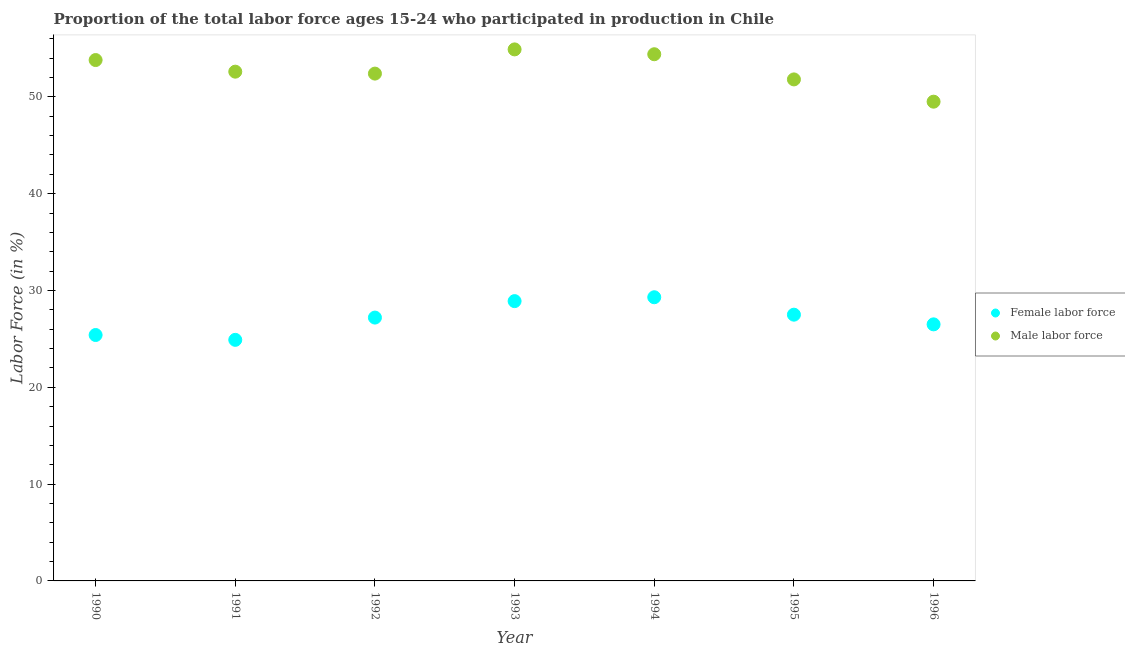How many different coloured dotlines are there?
Ensure brevity in your answer.  2. What is the percentage of female labor force in 1992?
Your answer should be very brief. 27.2. Across all years, what is the maximum percentage of male labour force?
Your answer should be very brief. 54.9. Across all years, what is the minimum percentage of female labor force?
Your answer should be very brief. 24.9. In which year was the percentage of male labour force maximum?
Offer a terse response. 1993. In which year was the percentage of male labour force minimum?
Provide a succinct answer. 1996. What is the total percentage of female labor force in the graph?
Offer a terse response. 189.7. What is the difference between the percentage of female labor force in 1994 and that in 1996?
Give a very brief answer. 2.8. What is the difference between the percentage of male labour force in 1995 and the percentage of female labor force in 1991?
Ensure brevity in your answer.  26.9. What is the average percentage of female labor force per year?
Provide a short and direct response. 27.1. In the year 1990, what is the difference between the percentage of male labour force and percentage of female labor force?
Provide a short and direct response. 28.4. In how many years, is the percentage of male labour force greater than 38 %?
Provide a short and direct response. 7. What is the ratio of the percentage of female labor force in 1992 to that in 1995?
Offer a very short reply. 0.99. What is the difference between the highest and the second highest percentage of female labor force?
Provide a succinct answer. 0.4. What is the difference between the highest and the lowest percentage of male labour force?
Offer a very short reply. 5.4. Is the percentage of male labour force strictly less than the percentage of female labor force over the years?
Make the answer very short. No. Where does the legend appear in the graph?
Provide a short and direct response. Center right. How many legend labels are there?
Your response must be concise. 2. How are the legend labels stacked?
Ensure brevity in your answer.  Vertical. What is the title of the graph?
Provide a succinct answer. Proportion of the total labor force ages 15-24 who participated in production in Chile. Does "Official creditors" appear as one of the legend labels in the graph?
Ensure brevity in your answer.  No. What is the label or title of the X-axis?
Offer a very short reply. Year. What is the Labor Force (in %) of Female labor force in 1990?
Your response must be concise. 25.4. What is the Labor Force (in %) of Male labor force in 1990?
Offer a very short reply. 53.8. What is the Labor Force (in %) in Female labor force in 1991?
Offer a terse response. 24.9. What is the Labor Force (in %) of Male labor force in 1991?
Your answer should be very brief. 52.6. What is the Labor Force (in %) in Female labor force in 1992?
Make the answer very short. 27.2. What is the Labor Force (in %) in Male labor force in 1992?
Provide a succinct answer. 52.4. What is the Labor Force (in %) of Female labor force in 1993?
Give a very brief answer. 28.9. What is the Labor Force (in %) of Male labor force in 1993?
Your answer should be compact. 54.9. What is the Labor Force (in %) in Female labor force in 1994?
Offer a very short reply. 29.3. What is the Labor Force (in %) of Male labor force in 1994?
Keep it short and to the point. 54.4. What is the Labor Force (in %) of Male labor force in 1995?
Provide a short and direct response. 51.8. What is the Labor Force (in %) of Female labor force in 1996?
Your answer should be very brief. 26.5. What is the Labor Force (in %) of Male labor force in 1996?
Keep it short and to the point. 49.5. Across all years, what is the maximum Labor Force (in %) in Female labor force?
Give a very brief answer. 29.3. Across all years, what is the maximum Labor Force (in %) in Male labor force?
Ensure brevity in your answer.  54.9. Across all years, what is the minimum Labor Force (in %) of Female labor force?
Ensure brevity in your answer.  24.9. Across all years, what is the minimum Labor Force (in %) of Male labor force?
Your response must be concise. 49.5. What is the total Labor Force (in %) in Female labor force in the graph?
Ensure brevity in your answer.  189.7. What is the total Labor Force (in %) of Male labor force in the graph?
Offer a terse response. 369.4. What is the difference between the Labor Force (in %) in Female labor force in 1990 and that in 1991?
Your answer should be compact. 0.5. What is the difference between the Labor Force (in %) in Male labor force in 1990 and that in 1993?
Provide a succinct answer. -1.1. What is the difference between the Labor Force (in %) of Male labor force in 1990 and that in 1995?
Make the answer very short. 2. What is the difference between the Labor Force (in %) in Female labor force in 1990 and that in 1996?
Make the answer very short. -1.1. What is the difference between the Labor Force (in %) in Female labor force in 1991 and that in 1992?
Your answer should be very brief. -2.3. What is the difference between the Labor Force (in %) of Male labor force in 1991 and that in 1993?
Ensure brevity in your answer.  -2.3. What is the difference between the Labor Force (in %) in Female labor force in 1991 and that in 1994?
Make the answer very short. -4.4. What is the difference between the Labor Force (in %) of Female labor force in 1992 and that in 1993?
Make the answer very short. -1.7. What is the difference between the Labor Force (in %) of Male labor force in 1992 and that in 1994?
Make the answer very short. -2. What is the difference between the Labor Force (in %) of Female labor force in 1992 and that in 1995?
Make the answer very short. -0.3. What is the difference between the Labor Force (in %) of Male labor force in 1992 and that in 1995?
Provide a short and direct response. 0.6. What is the difference between the Labor Force (in %) in Female labor force in 1992 and that in 1996?
Provide a succinct answer. 0.7. What is the difference between the Labor Force (in %) in Female labor force in 1994 and that in 1995?
Give a very brief answer. 1.8. What is the difference between the Labor Force (in %) of Male labor force in 1994 and that in 1995?
Offer a terse response. 2.6. What is the difference between the Labor Force (in %) of Male labor force in 1994 and that in 1996?
Ensure brevity in your answer.  4.9. What is the difference between the Labor Force (in %) of Female labor force in 1990 and the Labor Force (in %) of Male labor force in 1991?
Make the answer very short. -27.2. What is the difference between the Labor Force (in %) of Female labor force in 1990 and the Labor Force (in %) of Male labor force in 1993?
Offer a terse response. -29.5. What is the difference between the Labor Force (in %) in Female labor force in 1990 and the Labor Force (in %) in Male labor force in 1994?
Keep it short and to the point. -29. What is the difference between the Labor Force (in %) in Female labor force in 1990 and the Labor Force (in %) in Male labor force in 1995?
Ensure brevity in your answer.  -26.4. What is the difference between the Labor Force (in %) in Female labor force in 1990 and the Labor Force (in %) in Male labor force in 1996?
Provide a succinct answer. -24.1. What is the difference between the Labor Force (in %) in Female labor force in 1991 and the Labor Force (in %) in Male labor force in 1992?
Offer a terse response. -27.5. What is the difference between the Labor Force (in %) of Female labor force in 1991 and the Labor Force (in %) of Male labor force in 1993?
Make the answer very short. -30. What is the difference between the Labor Force (in %) in Female labor force in 1991 and the Labor Force (in %) in Male labor force in 1994?
Keep it short and to the point. -29.5. What is the difference between the Labor Force (in %) in Female labor force in 1991 and the Labor Force (in %) in Male labor force in 1995?
Keep it short and to the point. -26.9. What is the difference between the Labor Force (in %) in Female labor force in 1991 and the Labor Force (in %) in Male labor force in 1996?
Keep it short and to the point. -24.6. What is the difference between the Labor Force (in %) in Female labor force in 1992 and the Labor Force (in %) in Male labor force in 1993?
Offer a very short reply. -27.7. What is the difference between the Labor Force (in %) of Female labor force in 1992 and the Labor Force (in %) of Male labor force in 1994?
Offer a terse response. -27.2. What is the difference between the Labor Force (in %) in Female labor force in 1992 and the Labor Force (in %) in Male labor force in 1995?
Your response must be concise. -24.6. What is the difference between the Labor Force (in %) of Female labor force in 1992 and the Labor Force (in %) of Male labor force in 1996?
Offer a very short reply. -22.3. What is the difference between the Labor Force (in %) of Female labor force in 1993 and the Labor Force (in %) of Male labor force in 1994?
Provide a succinct answer. -25.5. What is the difference between the Labor Force (in %) of Female labor force in 1993 and the Labor Force (in %) of Male labor force in 1995?
Provide a succinct answer. -22.9. What is the difference between the Labor Force (in %) of Female labor force in 1993 and the Labor Force (in %) of Male labor force in 1996?
Your response must be concise. -20.6. What is the difference between the Labor Force (in %) in Female labor force in 1994 and the Labor Force (in %) in Male labor force in 1995?
Your answer should be compact. -22.5. What is the difference between the Labor Force (in %) in Female labor force in 1994 and the Labor Force (in %) in Male labor force in 1996?
Give a very brief answer. -20.2. What is the difference between the Labor Force (in %) of Female labor force in 1995 and the Labor Force (in %) of Male labor force in 1996?
Your answer should be very brief. -22. What is the average Labor Force (in %) of Female labor force per year?
Provide a succinct answer. 27.1. What is the average Labor Force (in %) in Male labor force per year?
Your response must be concise. 52.77. In the year 1990, what is the difference between the Labor Force (in %) of Female labor force and Labor Force (in %) of Male labor force?
Your answer should be very brief. -28.4. In the year 1991, what is the difference between the Labor Force (in %) in Female labor force and Labor Force (in %) in Male labor force?
Offer a very short reply. -27.7. In the year 1992, what is the difference between the Labor Force (in %) in Female labor force and Labor Force (in %) in Male labor force?
Give a very brief answer. -25.2. In the year 1993, what is the difference between the Labor Force (in %) of Female labor force and Labor Force (in %) of Male labor force?
Offer a very short reply. -26. In the year 1994, what is the difference between the Labor Force (in %) of Female labor force and Labor Force (in %) of Male labor force?
Give a very brief answer. -25.1. In the year 1995, what is the difference between the Labor Force (in %) of Female labor force and Labor Force (in %) of Male labor force?
Keep it short and to the point. -24.3. In the year 1996, what is the difference between the Labor Force (in %) in Female labor force and Labor Force (in %) in Male labor force?
Offer a terse response. -23. What is the ratio of the Labor Force (in %) in Female labor force in 1990 to that in 1991?
Your answer should be very brief. 1.02. What is the ratio of the Labor Force (in %) of Male labor force in 1990 to that in 1991?
Provide a succinct answer. 1.02. What is the ratio of the Labor Force (in %) in Female labor force in 1990 to that in 1992?
Offer a very short reply. 0.93. What is the ratio of the Labor Force (in %) of Male labor force in 1990 to that in 1992?
Make the answer very short. 1.03. What is the ratio of the Labor Force (in %) of Female labor force in 1990 to that in 1993?
Make the answer very short. 0.88. What is the ratio of the Labor Force (in %) of Female labor force in 1990 to that in 1994?
Provide a succinct answer. 0.87. What is the ratio of the Labor Force (in %) in Female labor force in 1990 to that in 1995?
Offer a very short reply. 0.92. What is the ratio of the Labor Force (in %) in Male labor force in 1990 to that in 1995?
Ensure brevity in your answer.  1.04. What is the ratio of the Labor Force (in %) of Female labor force in 1990 to that in 1996?
Offer a very short reply. 0.96. What is the ratio of the Labor Force (in %) of Male labor force in 1990 to that in 1996?
Your answer should be very brief. 1.09. What is the ratio of the Labor Force (in %) of Female labor force in 1991 to that in 1992?
Ensure brevity in your answer.  0.92. What is the ratio of the Labor Force (in %) of Female labor force in 1991 to that in 1993?
Your answer should be very brief. 0.86. What is the ratio of the Labor Force (in %) of Male labor force in 1991 to that in 1993?
Offer a terse response. 0.96. What is the ratio of the Labor Force (in %) in Female labor force in 1991 to that in 1994?
Make the answer very short. 0.85. What is the ratio of the Labor Force (in %) in Male labor force in 1991 to that in 1994?
Your response must be concise. 0.97. What is the ratio of the Labor Force (in %) of Female labor force in 1991 to that in 1995?
Provide a succinct answer. 0.91. What is the ratio of the Labor Force (in %) of Male labor force in 1991 to that in 1995?
Ensure brevity in your answer.  1.02. What is the ratio of the Labor Force (in %) in Female labor force in 1991 to that in 1996?
Ensure brevity in your answer.  0.94. What is the ratio of the Labor Force (in %) of Male labor force in 1991 to that in 1996?
Your answer should be very brief. 1.06. What is the ratio of the Labor Force (in %) of Female labor force in 1992 to that in 1993?
Ensure brevity in your answer.  0.94. What is the ratio of the Labor Force (in %) of Male labor force in 1992 to that in 1993?
Give a very brief answer. 0.95. What is the ratio of the Labor Force (in %) in Female labor force in 1992 to that in 1994?
Provide a succinct answer. 0.93. What is the ratio of the Labor Force (in %) in Male labor force in 1992 to that in 1994?
Offer a very short reply. 0.96. What is the ratio of the Labor Force (in %) in Male labor force in 1992 to that in 1995?
Give a very brief answer. 1.01. What is the ratio of the Labor Force (in %) in Female labor force in 1992 to that in 1996?
Offer a terse response. 1.03. What is the ratio of the Labor Force (in %) in Male labor force in 1992 to that in 1996?
Ensure brevity in your answer.  1.06. What is the ratio of the Labor Force (in %) in Female labor force in 1993 to that in 1994?
Provide a short and direct response. 0.99. What is the ratio of the Labor Force (in %) in Male labor force in 1993 to that in 1994?
Offer a very short reply. 1.01. What is the ratio of the Labor Force (in %) in Female labor force in 1993 to that in 1995?
Your answer should be very brief. 1.05. What is the ratio of the Labor Force (in %) in Male labor force in 1993 to that in 1995?
Ensure brevity in your answer.  1.06. What is the ratio of the Labor Force (in %) of Female labor force in 1993 to that in 1996?
Keep it short and to the point. 1.09. What is the ratio of the Labor Force (in %) of Male labor force in 1993 to that in 1996?
Provide a short and direct response. 1.11. What is the ratio of the Labor Force (in %) of Female labor force in 1994 to that in 1995?
Provide a succinct answer. 1.07. What is the ratio of the Labor Force (in %) of Male labor force in 1994 to that in 1995?
Provide a short and direct response. 1.05. What is the ratio of the Labor Force (in %) in Female labor force in 1994 to that in 1996?
Your response must be concise. 1.11. What is the ratio of the Labor Force (in %) in Male labor force in 1994 to that in 1996?
Your response must be concise. 1.1. What is the ratio of the Labor Force (in %) of Female labor force in 1995 to that in 1996?
Provide a succinct answer. 1.04. What is the ratio of the Labor Force (in %) of Male labor force in 1995 to that in 1996?
Ensure brevity in your answer.  1.05. What is the difference between the highest and the second highest Labor Force (in %) in Female labor force?
Ensure brevity in your answer.  0.4. What is the difference between the highest and the lowest Labor Force (in %) in Male labor force?
Provide a succinct answer. 5.4. 